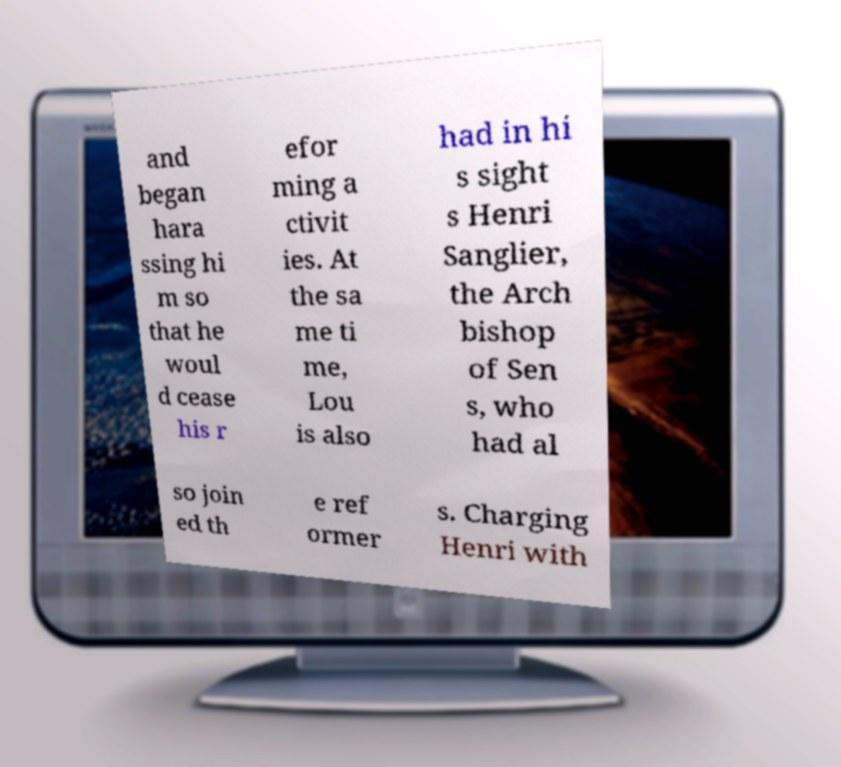There's text embedded in this image that I need extracted. Can you transcribe it verbatim? and began hara ssing hi m so that he woul d cease his r efor ming a ctivit ies. At the sa me ti me, Lou is also had in hi s sight s Henri Sanglier, the Arch bishop of Sen s, who had al so join ed th e ref ormer s. Charging Henri with 